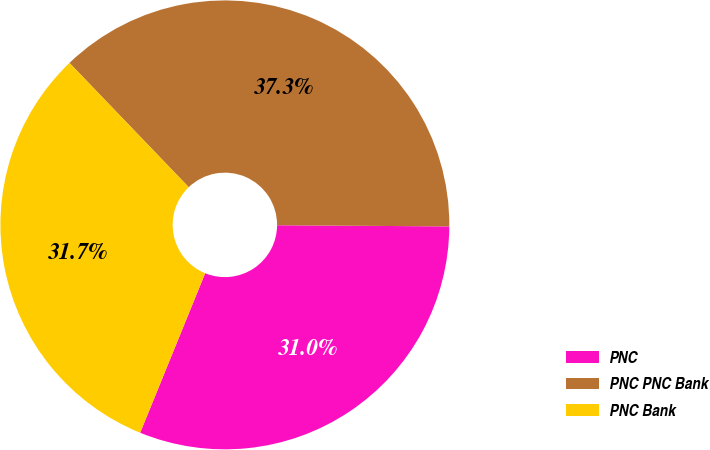<chart> <loc_0><loc_0><loc_500><loc_500><pie_chart><fcel>PNC<fcel>PNC PNC Bank<fcel>PNC Bank<nl><fcel>31.05%<fcel>37.28%<fcel>31.67%<nl></chart> 